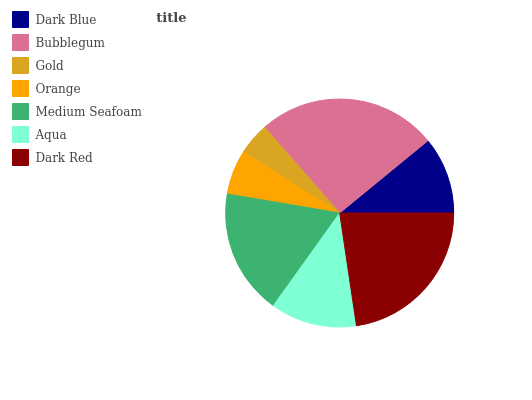Is Gold the minimum?
Answer yes or no. Yes. Is Bubblegum the maximum?
Answer yes or no. Yes. Is Bubblegum the minimum?
Answer yes or no. No. Is Gold the maximum?
Answer yes or no. No. Is Bubblegum greater than Gold?
Answer yes or no. Yes. Is Gold less than Bubblegum?
Answer yes or no. Yes. Is Gold greater than Bubblegum?
Answer yes or no. No. Is Bubblegum less than Gold?
Answer yes or no. No. Is Aqua the high median?
Answer yes or no. Yes. Is Aqua the low median?
Answer yes or no. Yes. Is Dark Blue the high median?
Answer yes or no. No. Is Bubblegum the low median?
Answer yes or no. No. 